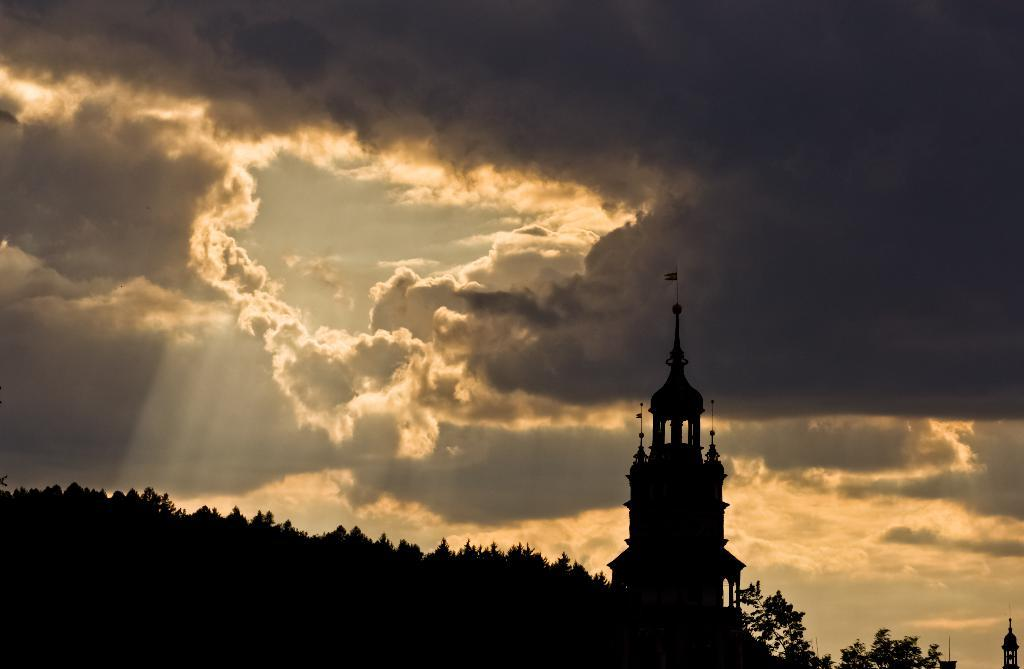What type of structures can be seen in the image? There are buildings in the image. What other natural elements are present in the image? There are trees in the image. What can be seen in the background of the image? The sky is visible in the background of the image. What is the condition of the sky in the image? Clouds are present in the sky. What type of underwear is hanging on the clothesline in the image? There is no clothesline or underwear present in the image. How many attempts were made to catch the train in the image? There is no train or attempt to catch a train depicted in the image. 